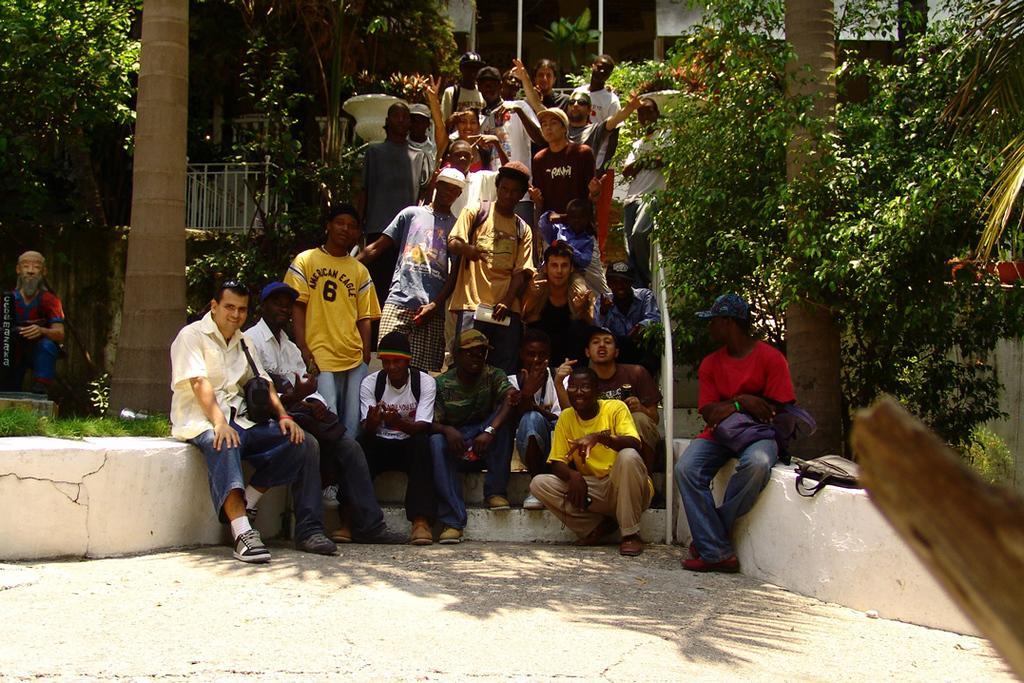In one or two sentences, can you explain what this image depicts? In this image we can see a group of people are standing on a staircase, and some are sitting, there are trees, there is a grass, there is a building. 